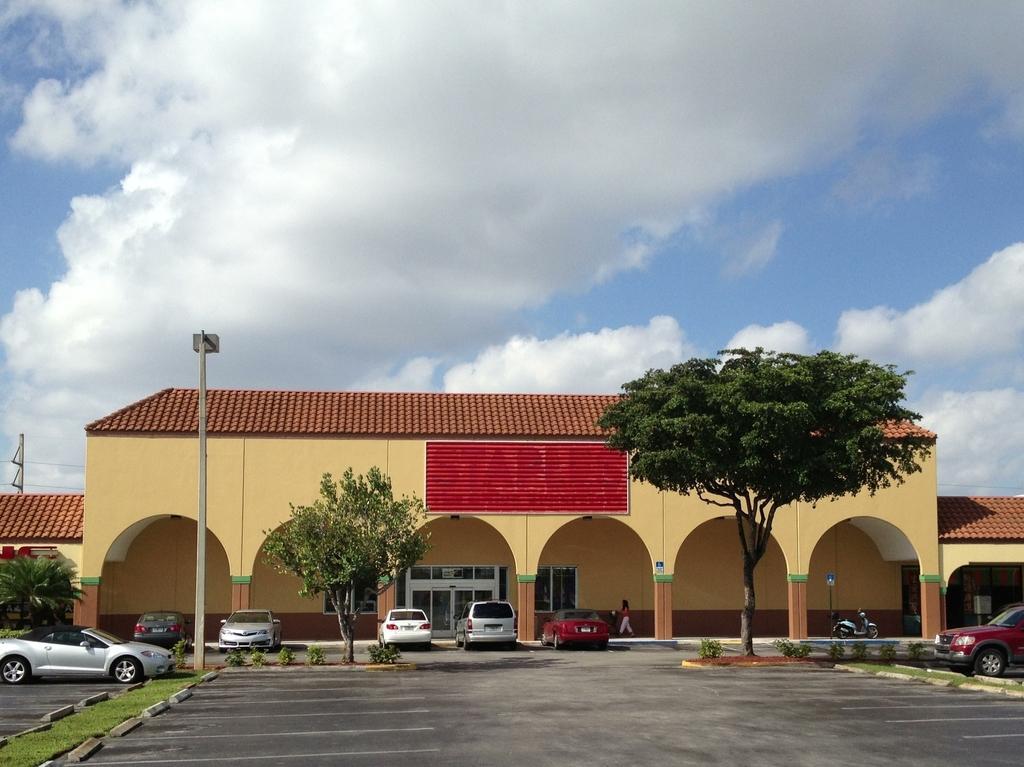Describe this image in one or two sentences. There is a building and there are few vehicles parked in front of it and there are trees in front of it. 